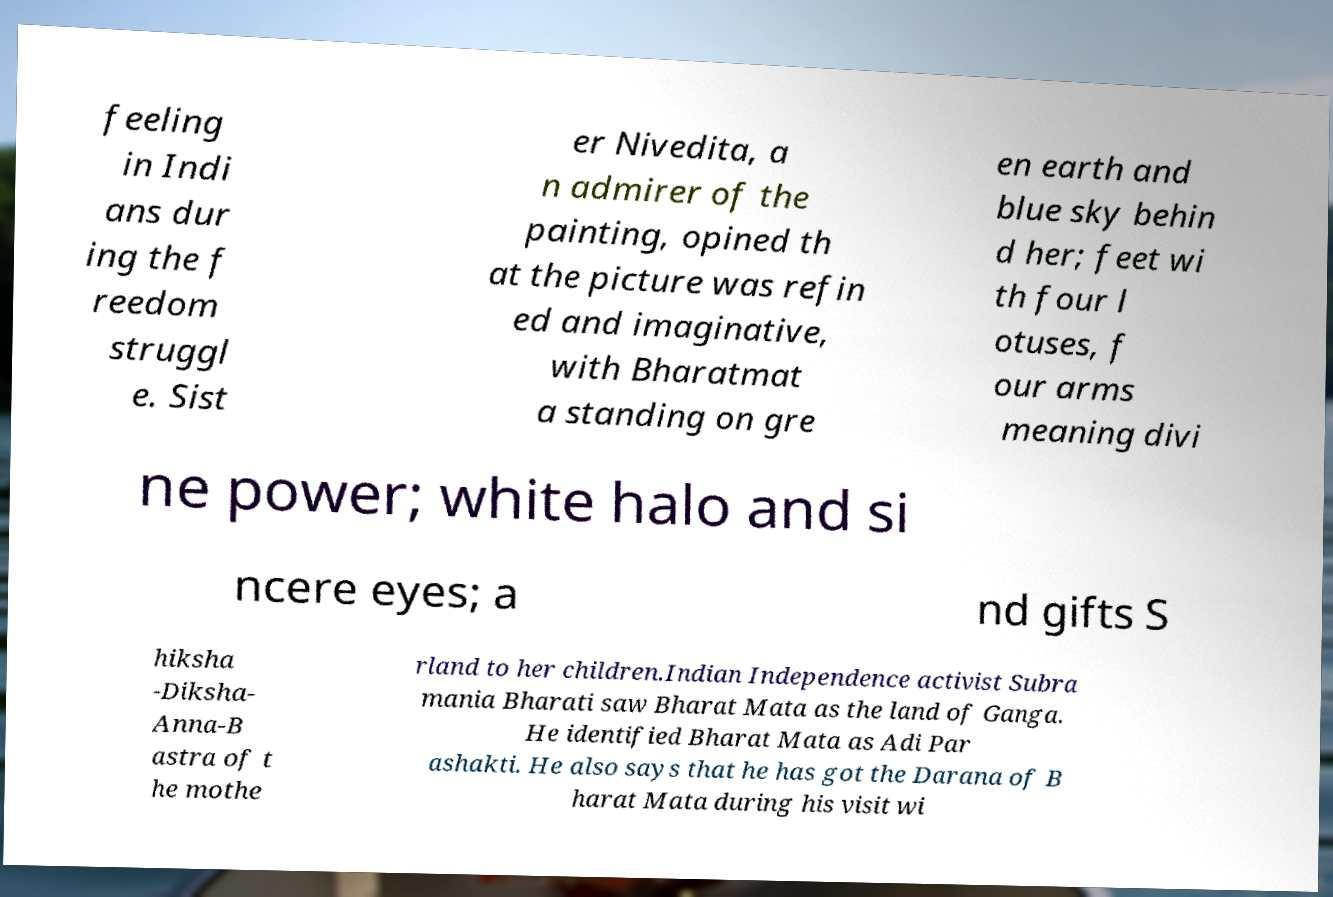Please read and relay the text visible in this image. What does it say? feeling in Indi ans dur ing the f reedom struggl e. Sist er Nivedita, a n admirer of the painting, opined th at the picture was refin ed and imaginative, with Bharatmat a standing on gre en earth and blue sky behin d her; feet wi th four l otuses, f our arms meaning divi ne power; white halo and si ncere eyes; a nd gifts S hiksha -Diksha- Anna-B astra of t he mothe rland to her children.Indian Independence activist Subra mania Bharati saw Bharat Mata as the land of Ganga. He identified Bharat Mata as Adi Par ashakti. He also says that he has got the Darana of B harat Mata during his visit wi 